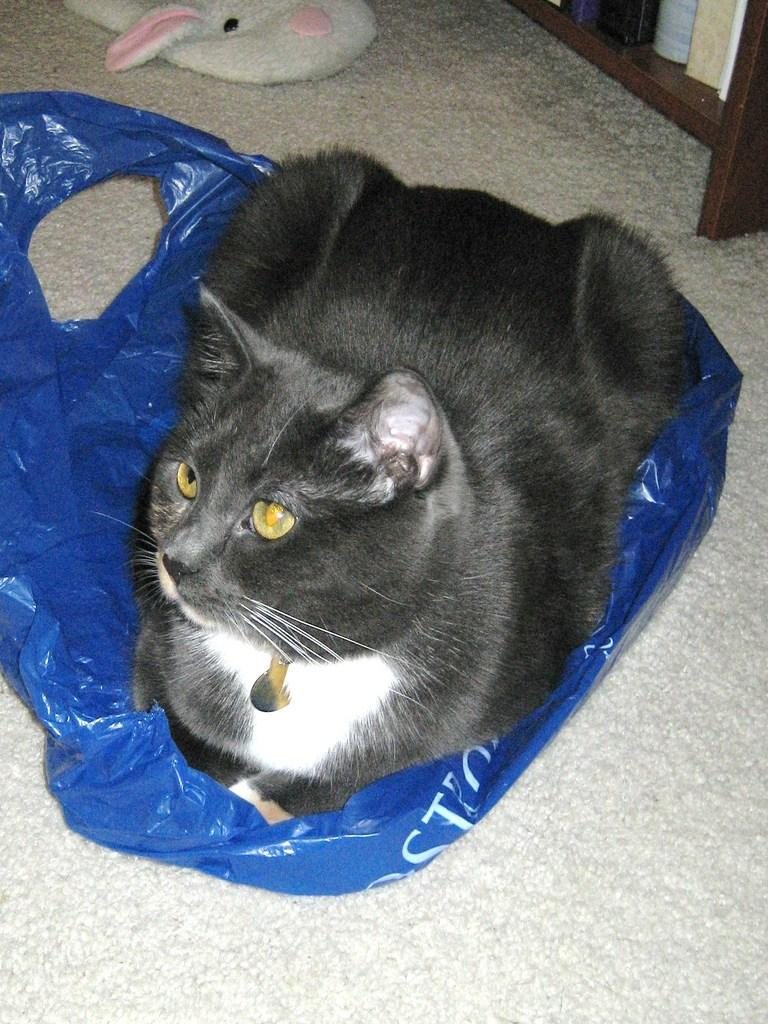What is the color of the object sitting on the blue cover in the image? The object is black, likely a dog or cat. What is the blue cover placed on in the image? The blue cover is on the floor. What other item can be seen on the floor in the image? There is a toy on the floor in the image. Where are the books located in the image? The books are on a rack in the image. How does the sun affect the throat of the black object in the image? The image does not show the sun or any indication of the black object's throat, so it is not possible to answer that question. 